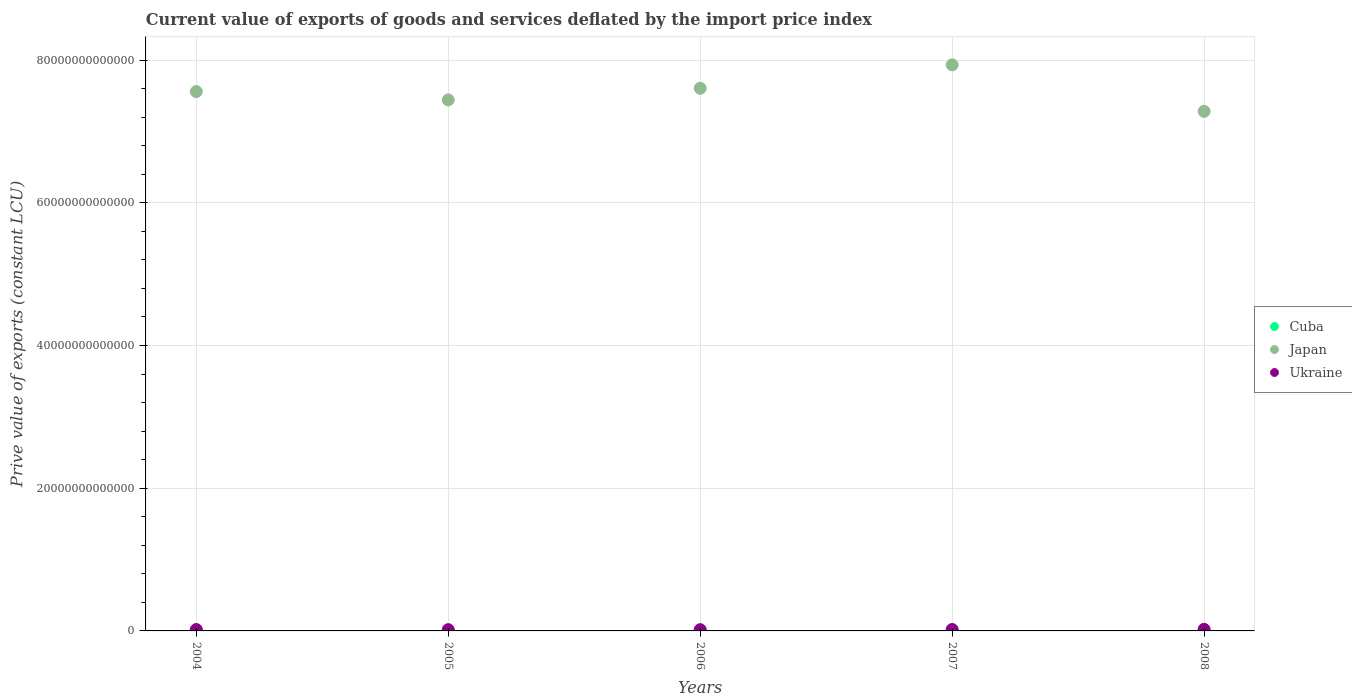What is the prive value of exports in Ukraine in 2004?
Ensure brevity in your answer.  1.94e+11. Across all years, what is the maximum prive value of exports in Ukraine?
Your answer should be very brief. 2.23e+11. Across all years, what is the minimum prive value of exports in Japan?
Your answer should be very brief. 7.28e+13. What is the total prive value of exports in Japan in the graph?
Your response must be concise. 3.78e+14. What is the difference between the prive value of exports in Cuba in 2005 and that in 2008?
Give a very brief answer. 5.12e+08. What is the difference between the prive value of exports in Ukraine in 2007 and the prive value of exports in Cuba in 2008?
Your response must be concise. 1.90e+11. What is the average prive value of exports in Japan per year?
Keep it short and to the point. 7.56e+13. In the year 2006, what is the difference between the prive value of exports in Ukraine and prive value of exports in Cuba?
Give a very brief answer. 1.66e+11. What is the ratio of the prive value of exports in Cuba in 2004 to that in 2007?
Your answer should be compact. 0.61. Is the difference between the prive value of exports in Ukraine in 2007 and 2008 greater than the difference between the prive value of exports in Cuba in 2007 and 2008?
Your response must be concise. No. What is the difference between the highest and the second highest prive value of exports in Japan?
Your answer should be very brief. 3.28e+12. What is the difference between the highest and the lowest prive value of exports in Japan?
Your answer should be very brief. 6.51e+12. In how many years, is the prive value of exports in Japan greater than the average prive value of exports in Japan taken over all years?
Your answer should be very brief. 2. Is the sum of the prive value of exports in Ukraine in 2006 and 2007 greater than the maximum prive value of exports in Cuba across all years?
Offer a terse response. Yes. Is the prive value of exports in Japan strictly less than the prive value of exports in Ukraine over the years?
Provide a succinct answer. No. How many years are there in the graph?
Keep it short and to the point. 5. What is the difference between two consecutive major ticks on the Y-axis?
Your answer should be compact. 2.00e+13. Are the values on the major ticks of Y-axis written in scientific E-notation?
Your response must be concise. No. Does the graph contain any zero values?
Ensure brevity in your answer.  No. Does the graph contain grids?
Your answer should be very brief. Yes. Where does the legend appear in the graph?
Your answer should be very brief. Center right. How many legend labels are there?
Ensure brevity in your answer.  3. What is the title of the graph?
Provide a short and direct response. Current value of exports of goods and services deflated by the import price index. Does "South Asia" appear as one of the legend labels in the graph?
Your answer should be very brief. No. What is the label or title of the Y-axis?
Make the answer very short. Prive value of exports (constant LCU). What is the Prive value of exports (constant LCU) of Cuba in 2004?
Provide a succinct answer. 6.52e+09. What is the Prive value of exports (constant LCU) in Japan in 2004?
Offer a very short reply. 7.56e+13. What is the Prive value of exports (constant LCU) of Ukraine in 2004?
Ensure brevity in your answer.  1.94e+11. What is the Prive value of exports (constant LCU) in Cuba in 2005?
Keep it short and to the point. 8.96e+09. What is the Prive value of exports (constant LCU) of Japan in 2005?
Keep it short and to the point. 7.44e+13. What is the Prive value of exports (constant LCU) of Ukraine in 2005?
Offer a very short reply. 1.77e+11. What is the Prive value of exports (constant LCU) of Cuba in 2006?
Offer a terse response. 9.54e+09. What is the Prive value of exports (constant LCU) of Japan in 2006?
Keep it short and to the point. 7.60e+13. What is the Prive value of exports (constant LCU) of Ukraine in 2006?
Ensure brevity in your answer.  1.75e+11. What is the Prive value of exports (constant LCU) in Cuba in 2007?
Give a very brief answer. 1.07e+1. What is the Prive value of exports (constant LCU) in Japan in 2007?
Offer a terse response. 7.93e+13. What is the Prive value of exports (constant LCU) of Ukraine in 2007?
Your answer should be very brief. 1.98e+11. What is the Prive value of exports (constant LCU) of Cuba in 2008?
Keep it short and to the point. 8.45e+09. What is the Prive value of exports (constant LCU) in Japan in 2008?
Ensure brevity in your answer.  7.28e+13. What is the Prive value of exports (constant LCU) of Ukraine in 2008?
Provide a succinct answer. 2.23e+11. Across all years, what is the maximum Prive value of exports (constant LCU) in Cuba?
Keep it short and to the point. 1.07e+1. Across all years, what is the maximum Prive value of exports (constant LCU) in Japan?
Give a very brief answer. 7.93e+13. Across all years, what is the maximum Prive value of exports (constant LCU) of Ukraine?
Offer a terse response. 2.23e+11. Across all years, what is the minimum Prive value of exports (constant LCU) in Cuba?
Provide a succinct answer. 6.52e+09. Across all years, what is the minimum Prive value of exports (constant LCU) of Japan?
Make the answer very short. 7.28e+13. Across all years, what is the minimum Prive value of exports (constant LCU) in Ukraine?
Offer a terse response. 1.75e+11. What is the total Prive value of exports (constant LCU) of Cuba in the graph?
Provide a short and direct response. 4.42e+1. What is the total Prive value of exports (constant LCU) in Japan in the graph?
Give a very brief answer. 3.78e+14. What is the total Prive value of exports (constant LCU) of Ukraine in the graph?
Keep it short and to the point. 9.67e+11. What is the difference between the Prive value of exports (constant LCU) in Cuba in 2004 and that in 2005?
Your response must be concise. -2.45e+09. What is the difference between the Prive value of exports (constant LCU) of Japan in 2004 and that in 2005?
Ensure brevity in your answer.  1.17e+12. What is the difference between the Prive value of exports (constant LCU) in Ukraine in 2004 and that in 2005?
Offer a terse response. 1.74e+1. What is the difference between the Prive value of exports (constant LCU) of Cuba in 2004 and that in 2006?
Ensure brevity in your answer.  -3.02e+09. What is the difference between the Prive value of exports (constant LCU) of Japan in 2004 and that in 2006?
Your answer should be compact. -4.66e+11. What is the difference between the Prive value of exports (constant LCU) in Ukraine in 2004 and that in 2006?
Your answer should be compact. 1.91e+1. What is the difference between the Prive value of exports (constant LCU) of Cuba in 2004 and that in 2007?
Keep it short and to the point. -4.23e+09. What is the difference between the Prive value of exports (constant LCU) of Japan in 2004 and that in 2007?
Ensure brevity in your answer.  -3.74e+12. What is the difference between the Prive value of exports (constant LCU) in Ukraine in 2004 and that in 2007?
Your response must be concise. -4.13e+09. What is the difference between the Prive value of exports (constant LCU) of Cuba in 2004 and that in 2008?
Your answer should be compact. -1.93e+09. What is the difference between the Prive value of exports (constant LCU) of Japan in 2004 and that in 2008?
Make the answer very short. 2.77e+12. What is the difference between the Prive value of exports (constant LCU) of Ukraine in 2004 and that in 2008?
Your response must be concise. -2.85e+1. What is the difference between the Prive value of exports (constant LCU) of Cuba in 2005 and that in 2006?
Make the answer very short. -5.80e+08. What is the difference between the Prive value of exports (constant LCU) in Japan in 2005 and that in 2006?
Give a very brief answer. -1.63e+12. What is the difference between the Prive value of exports (constant LCU) of Ukraine in 2005 and that in 2006?
Make the answer very short. 1.74e+09. What is the difference between the Prive value of exports (constant LCU) in Cuba in 2005 and that in 2007?
Your answer should be compact. -1.78e+09. What is the difference between the Prive value of exports (constant LCU) of Japan in 2005 and that in 2007?
Offer a terse response. -4.91e+12. What is the difference between the Prive value of exports (constant LCU) of Ukraine in 2005 and that in 2007?
Your answer should be compact. -2.15e+1. What is the difference between the Prive value of exports (constant LCU) of Cuba in 2005 and that in 2008?
Offer a terse response. 5.12e+08. What is the difference between the Prive value of exports (constant LCU) in Japan in 2005 and that in 2008?
Provide a short and direct response. 1.60e+12. What is the difference between the Prive value of exports (constant LCU) of Ukraine in 2005 and that in 2008?
Ensure brevity in your answer.  -4.59e+1. What is the difference between the Prive value of exports (constant LCU) of Cuba in 2006 and that in 2007?
Your response must be concise. -1.20e+09. What is the difference between the Prive value of exports (constant LCU) in Japan in 2006 and that in 2007?
Your answer should be very brief. -3.28e+12. What is the difference between the Prive value of exports (constant LCU) of Ukraine in 2006 and that in 2007?
Keep it short and to the point. -2.33e+1. What is the difference between the Prive value of exports (constant LCU) in Cuba in 2006 and that in 2008?
Ensure brevity in your answer.  1.09e+09. What is the difference between the Prive value of exports (constant LCU) of Japan in 2006 and that in 2008?
Ensure brevity in your answer.  3.23e+12. What is the difference between the Prive value of exports (constant LCU) of Ukraine in 2006 and that in 2008?
Your answer should be compact. -4.76e+1. What is the difference between the Prive value of exports (constant LCU) in Cuba in 2007 and that in 2008?
Your answer should be very brief. 2.30e+09. What is the difference between the Prive value of exports (constant LCU) of Japan in 2007 and that in 2008?
Your response must be concise. 6.51e+12. What is the difference between the Prive value of exports (constant LCU) of Ukraine in 2007 and that in 2008?
Keep it short and to the point. -2.44e+1. What is the difference between the Prive value of exports (constant LCU) in Cuba in 2004 and the Prive value of exports (constant LCU) in Japan in 2005?
Provide a succinct answer. -7.44e+13. What is the difference between the Prive value of exports (constant LCU) in Cuba in 2004 and the Prive value of exports (constant LCU) in Ukraine in 2005?
Your answer should be very brief. -1.70e+11. What is the difference between the Prive value of exports (constant LCU) of Japan in 2004 and the Prive value of exports (constant LCU) of Ukraine in 2005?
Provide a short and direct response. 7.54e+13. What is the difference between the Prive value of exports (constant LCU) in Cuba in 2004 and the Prive value of exports (constant LCU) in Japan in 2006?
Ensure brevity in your answer.  -7.60e+13. What is the difference between the Prive value of exports (constant LCU) of Cuba in 2004 and the Prive value of exports (constant LCU) of Ukraine in 2006?
Your response must be concise. -1.69e+11. What is the difference between the Prive value of exports (constant LCU) in Japan in 2004 and the Prive value of exports (constant LCU) in Ukraine in 2006?
Keep it short and to the point. 7.54e+13. What is the difference between the Prive value of exports (constant LCU) in Cuba in 2004 and the Prive value of exports (constant LCU) in Japan in 2007?
Give a very brief answer. -7.93e+13. What is the difference between the Prive value of exports (constant LCU) in Cuba in 2004 and the Prive value of exports (constant LCU) in Ukraine in 2007?
Provide a short and direct response. -1.92e+11. What is the difference between the Prive value of exports (constant LCU) in Japan in 2004 and the Prive value of exports (constant LCU) in Ukraine in 2007?
Provide a short and direct response. 7.54e+13. What is the difference between the Prive value of exports (constant LCU) of Cuba in 2004 and the Prive value of exports (constant LCU) of Japan in 2008?
Make the answer very short. -7.28e+13. What is the difference between the Prive value of exports (constant LCU) of Cuba in 2004 and the Prive value of exports (constant LCU) of Ukraine in 2008?
Offer a very short reply. -2.16e+11. What is the difference between the Prive value of exports (constant LCU) in Japan in 2004 and the Prive value of exports (constant LCU) in Ukraine in 2008?
Your answer should be very brief. 7.54e+13. What is the difference between the Prive value of exports (constant LCU) in Cuba in 2005 and the Prive value of exports (constant LCU) in Japan in 2006?
Your answer should be compact. -7.60e+13. What is the difference between the Prive value of exports (constant LCU) in Cuba in 2005 and the Prive value of exports (constant LCU) in Ukraine in 2006?
Your answer should be compact. -1.66e+11. What is the difference between the Prive value of exports (constant LCU) of Japan in 2005 and the Prive value of exports (constant LCU) of Ukraine in 2006?
Make the answer very short. 7.42e+13. What is the difference between the Prive value of exports (constant LCU) in Cuba in 2005 and the Prive value of exports (constant LCU) in Japan in 2007?
Your answer should be compact. -7.93e+13. What is the difference between the Prive value of exports (constant LCU) of Cuba in 2005 and the Prive value of exports (constant LCU) of Ukraine in 2007?
Give a very brief answer. -1.89e+11. What is the difference between the Prive value of exports (constant LCU) of Japan in 2005 and the Prive value of exports (constant LCU) of Ukraine in 2007?
Make the answer very short. 7.42e+13. What is the difference between the Prive value of exports (constant LCU) of Cuba in 2005 and the Prive value of exports (constant LCU) of Japan in 2008?
Give a very brief answer. -7.28e+13. What is the difference between the Prive value of exports (constant LCU) of Cuba in 2005 and the Prive value of exports (constant LCU) of Ukraine in 2008?
Ensure brevity in your answer.  -2.14e+11. What is the difference between the Prive value of exports (constant LCU) of Japan in 2005 and the Prive value of exports (constant LCU) of Ukraine in 2008?
Make the answer very short. 7.42e+13. What is the difference between the Prive value of exports (constant LCU) of Cuba in 2006 and the Prive value of exports (constant LCU) of Japan in 2007?
Keep it short and to the point. -7.93e+13. What is the difference between the Prive value of exports (constant LCU) of Cuba in 2006 and the Prive value of exports (constant LCU) of Ukraine in 2007?
Provide a succinct answer. -1.89e+11. What is the difference between the Prive value of exports (constant LCU) of Japan in 2006 and the Prive value of exports (constant LCU) of Ukraine in 2007?
Keep it short and to the point. 7.59e+13. What is the difference between the Prive value of exports (constant LCU) of Cuba in 2006 and the Prive value of exports (constant LCU) of Japan in 2008?
Provide a short and direct response. -7.28e+13. What is the difference between the Prive value of exports (constant LCU) in Cuba in 2006 and the Prive value of exports (constant LCU) in Ukraine in 2008?
Make the answer very short. -2.13e+11. What is the difference between the Prive value of exports (constant LCU) of Japan in 2006 and the Prive value of exports (constant LCU) of Ukraine in 2008?
Provide a short and direct response. 7.58e+13. What is the difference between the Prive value of exports (constant LCU) of Cuba in 2007 and the Prive value of exports (constant LCU) of Japan in 2008?
Your answer should be compact. -7.28e+13. What is the difference between the Prive value of exports (constant LCU) of Cuba in 2007 and the Prive value of exports (constant LCU) of Ukraine in 2008?
Your answer should be very brief. -2.12e+11. What is the difference between the Prive value of exports (constant LCU) in Japan in 2007 and the Prive value of exports (constant LCU) in Ukraine in 2008?
Your answer should be compact. 7.91e+13. What is the average Prive value of exports (constant LCU) in Cuba per year?
Provide a short and direct response. 8.84e+09. What is the average Prive value of exports (constant LCU) of Japan per year?
Ensure brevity in your answer.  7.56e+13. What is the average Prive value of exports (constant LCU) of Ukraine per year?
Provide a short and direct response. 1.93e+11. In the year 2004, what is the difference between the Prive value of exports (constant LCU) of Cuba and Prive value of exports (constant LCU) of Japan?
Your response must be concise. -7.56e+13. In the year 2004, what is the difference between the Prive value of exports (constant LCU) in Cuba and Prive value of exports (constant LCU) in Ukraine?
Your answer should be very brief. -1.88e+11. In the year 2004, what is the difference between the Prive value of exports (constant LCU) of Japan and Prive value of exports (constant LCU) of Ukraine?
Your answer should be very brief. 7.54e+13. In the year 2005, what is the difference between the Prive value of exports (constant LCU) in Cuba and Prive value of exports (constant LCU) in Japan?
Keep it short and to the point. -7.44e+13. In the year 2005, what is the difference between the Prive value of exports (constant LCU) in Cuba and Prive value of exports (constant LCU) in Ukraine?
Ensure brevity in your answer.  -1.68e+11. In the year 2005, what is the difference between the Prive value of exports (constant LCU) in Japan and Prive value of exports (constant LCU) in Ukraine?
Give a very brief answer. 7.42e+13. In the year 2006, what is the difference between the Prive value of exports (constant LCU) of Cuba and Prive value of exports (constant LCU) of Japan?
Your answer should be compact. -7.60e+13. In the year 2006, what is the difference between the Prive value of exports (constant LCU) in Cuba and Prive value of exports (constant LCU) in Ukraine?
Offer a terse response. -1.66e+11. In the year 2006, what is the difference between the Prive value of exports (constant LCU) in Japan and Prive value of exports (constant LCU) in Ukraine?
Make the answer very short. 7.59e+13. In the year 2007, what is the difference between the Prive value of exports (constant LCU) in Cuba and Prive value of exports (constant LCU) in Japan?
Offer a very short reply. -7.93e+13. In the year 2007, what is the difference between the Prive value of exports (constant LCU) in Cuba and Prive value of exports (constant LCU) in Ukraine?
Ensure brevity in your answer.  -1.88e+11. In the year 2007, what is the difference between the Prive value of exports (constant LCU) of Japan and Prive value of exports (constant LCU) of Ukraine?
Give a very brief answer. 7.91e+13. In the year 2008, what is the difference between the Prive value of exports (constant LCU) in Cuba and Prive value of exports (constant LCU) in Japan?
Offer a very short reply. -7.28e+13. In the year 2008, what is the difference between the Prive value of exports (constant LCU) in Cuba and Prive value of exports (constant LCU) in Ukraine?
Provide a short and direct response. -2.14e+11. In the year 2008, what is the difference between the Prive value of exports (constant LCU) in Japan and Prive value of exports (constant LCU) in Ukraine?
Make the answer very short. 7.26e+13. What is the ratio of the Prive value of exports (constant LCU) of Cuba in 2004 to that in 2005?
Provide a succinct answer. 0.73. What is the ratio of the Prive value of exports (constant LCU) in Japan in 2004 to that in 2005?
Ensure brevity in your answer.  1.02. What is the ratio of the Prive value of exports (constant LCU) in Ukraine in 2004 to that in 2005?
Your answer should be very brief. 1.1. What is the ratio of the Prive value of exports (constant LCU) of Cuba in 2004 to that in 2006?
Give a very brief answer. 0.68. What is the ratio of the Prive value of exports (constant LCU) in Ukraine in 2004 to that in 2006?
Provide a succinct answer. 1.11. What is the ratio of the Prive value of exports (constant LCU) in Cuba in 2004 to that in 2007?
Offer a very short reply. 0.61. What is the ratio of the Prive value of exports (constant LCU) in Japan in 2004 to that in 2007?
Offer a very short reply. 0.95. What is the ratio of the Prive value of exports (constant LCU) of Ukraine in 2004 to that in 2007?
Make the answer very short. 0.98. What is the ratio of the Prive value of exports (constant LCU) of Cuba in 2004 to that in 2008?
Your answer should be very brief. 0.77. What is the ratio of the Prive value of exports (constant LCU) of Japan in 2004 to that in 2008?
Your response must be concise. 1.04. What is the ratio of the Prive value of exports (constant LCU) in Ukraine in 2004 to that in 2008?
Your answer should be compact. 0.87. What is the ratio of the Prive value of exports (constant LCU) of Cuba in 2005 to that in 2006?
Make the answer very short. 0.94. What is the ratio of the Prive value of exports (constant LCU) of Japan in 2005 to that in 2006?
Provide a short and direct response. 0.98. What is the ratio of the Prive value of exports (constant LCU) in Ukraine in 2005 to that in 2006?
Your response must be concise. 1.01. What is the ratio of the Prive value of exports (constant LCU) in Cuba in 2005 to that in 2007?
Offer a very short reply. 0.83. What is the ratio of the Prive value of exports (constant LCU) of Japan in 2005 to that in 2007?
Provide a succinct answer. 0.94. What is the ratio of the Prive value of exports (constant LCU) in Ukraine in 2005 to that in 2007?
Ensure brevity in your answer.  0.89. What is the ratio of the Prive value of exports (constant LCU) in Cuba in 2005 to that in 2008?
Your answer should be very brief. 1.06. What is the ratio of the Prive value of exports (constant LCU) in Ukraine in 2005 to that in 2008?
Your answer should be compact. 0.79. What is the ratio of the Prive value of exports (constant LCU) in Cuba in 2006 to that in 2007?
Your answer should be very brief. 0.89. What is the ratio of the Prive value of exports (constant LCU) of Japan in 2006 to that in 2007?
Keep it short and to the point. 0.96. What is the ratio of the Prive value of exports (constant LCU) of Ukraine in 2006 to that in 2007?
Ensure brevity in your answer.  0.88. What is the ratio of the Prive value of exports (constant LCU) in Cuba in 2006 to that in 2008?
Your answer should be compact. 1.13. What is the ratio of the Prive value of exports (constant LCU) in Japan in 2006 to that in 2008?
Make the answer very short. 1.04. What is the ratio of the Prive value of exports (constant LCU) in Ukraine in 2006 to that in 2008?
Your response must be concise. 0.79. What is the ratio of the Prive value of exports (constant LCU) of Cuba in 2007 to that in 2008?
Offer a very short reply. 1.27. What is the ratio of the Prive value of exports (constant LCU) in Japan in 2007 to that in 2008?
Ensure brevity in your answer.  1.09. What is the ratio of the Prive value of exports (constant LCU) in Ukraine in 2007 to that in 2008?
Offer a very short reply. 0.89. What is the difference between the highest and the second highest Prive value of exports (constant LCU) of Cuba?
Provide a succinct answer. 1.20e+09. What is the difference between the highest and the second highest Prive value of exports (constant LCU) in Japan?
Give a very brief answer. 3.28e+12. What is the difference between the highest and the second highest Prive value of exports (constant LCU) of Ukraine?
Make the answer very short. 2.44e+1. What is the difference between the highest and the lowest Prive value of exports (constant LCU) of Cuba?
Provide a short and direct response. 4.23e+09. What is the difference between the highest and the lowest Prive value of exports (constant LCU) of Japan?
Give a very brief answer. 6.51e+12. What is the difference between the highest and the lowest Prive value of exports (constant LCU) of Ukraine?
Provide a short and direct response. 4.76e+1. 